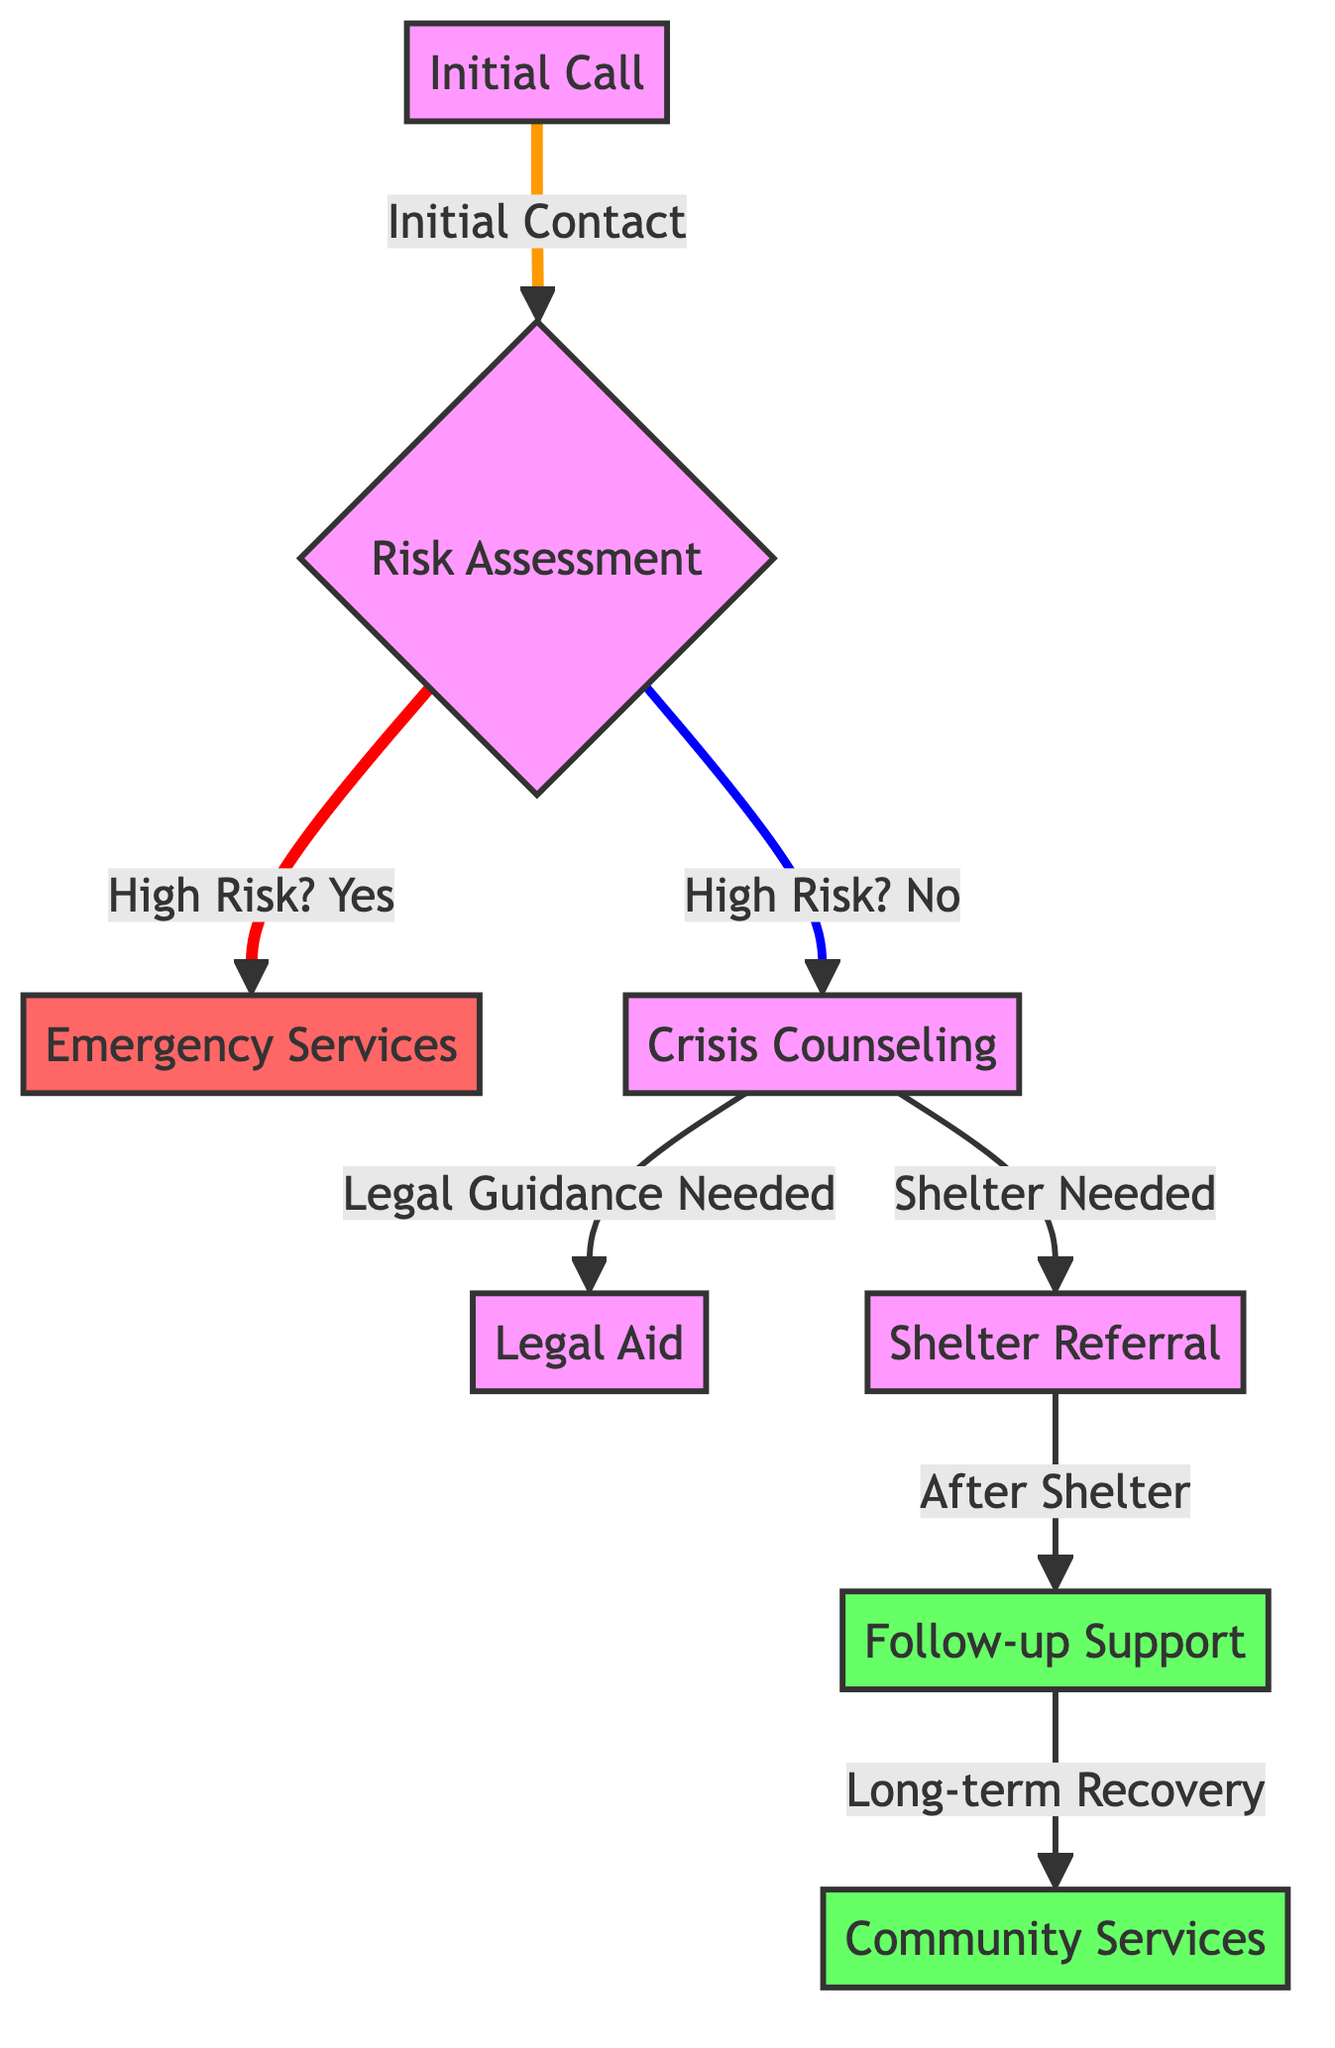What is the first step in the helpline response chain? The first step in the helpline response chain is the "Initial Call" where a victim reaches out for help. This node is indicated at the very beginning of the diagram.
Answer: Initial Call How many different paths can be taken after the Risk Assessment? After the "Risk Assessment" node, there are two paths: one for high risk leading to "Emergency Services" and another for low risk leading to "Crisis Counseling." This means there are two distinct outcomes based on the risk assessment made.
Answer: 2 What happens if the Risk Assessment shows high risk? If the Risk Assessment indicates high risk, the next step is to contact "Emergency Services," signifying an immediate response is required for safety.
Answer: Emergency Services What is the final step after "Follow-up Support"? The final step in the workflow after "Follow-up Support" is the "Community Services," which signifies long-term recovery options available to the victim.
Answer: Community Services How many total nodes are there in the diagram? The total nodes in the diagram include: Initial Call, Risk Assessment, Emergency Services, Crisis Counseling, Legal Aid, Shelter Referral, Follow-up Support, and Community Services, summing up to eight nodes.
Answer: 8 What is the purpose of the "Crisis Counseling" step? The "Crisis Counseling" step serves to provide emotional support and guidance to the victim after the risk assessment if they are assessed as not being in high risk. It is a critical point for intervention before further services are considered.
Answer: Emotional support Which node indicates that legal assistance might be needed? The node labeled "Legal Aid" indicates that legal assistance might be necessary, as it follows directly from the "Crisis Counseling" node when legal guidance is deemed necessary.
Answer: Legal Aid What color represents high-risk interventions in the diagram? The nodes representing high-risk interventions are colored red, indicating an urgent and critical response needed for the victim's safety.
Answer: Red What response follows a shelter referral? The response that follows a "Shelter Referral" is "Follow-up Support," ensuring continued assistance and care for the victim after their immediate shelter needs are met.
Answer: Follow-up Support 